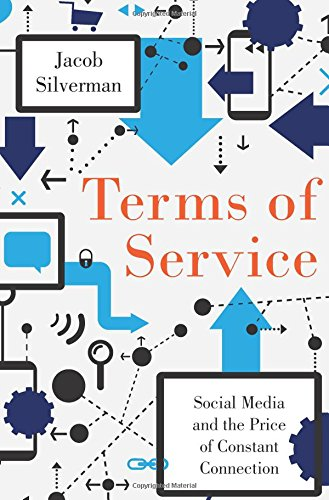How has the author structured the arguments in the book? Jacob Silverman structures his arguments through a mix of personal anecdotes, detailed research, and case studies to illustrate the pervasive effects of social media on privacy, identity, and community. 